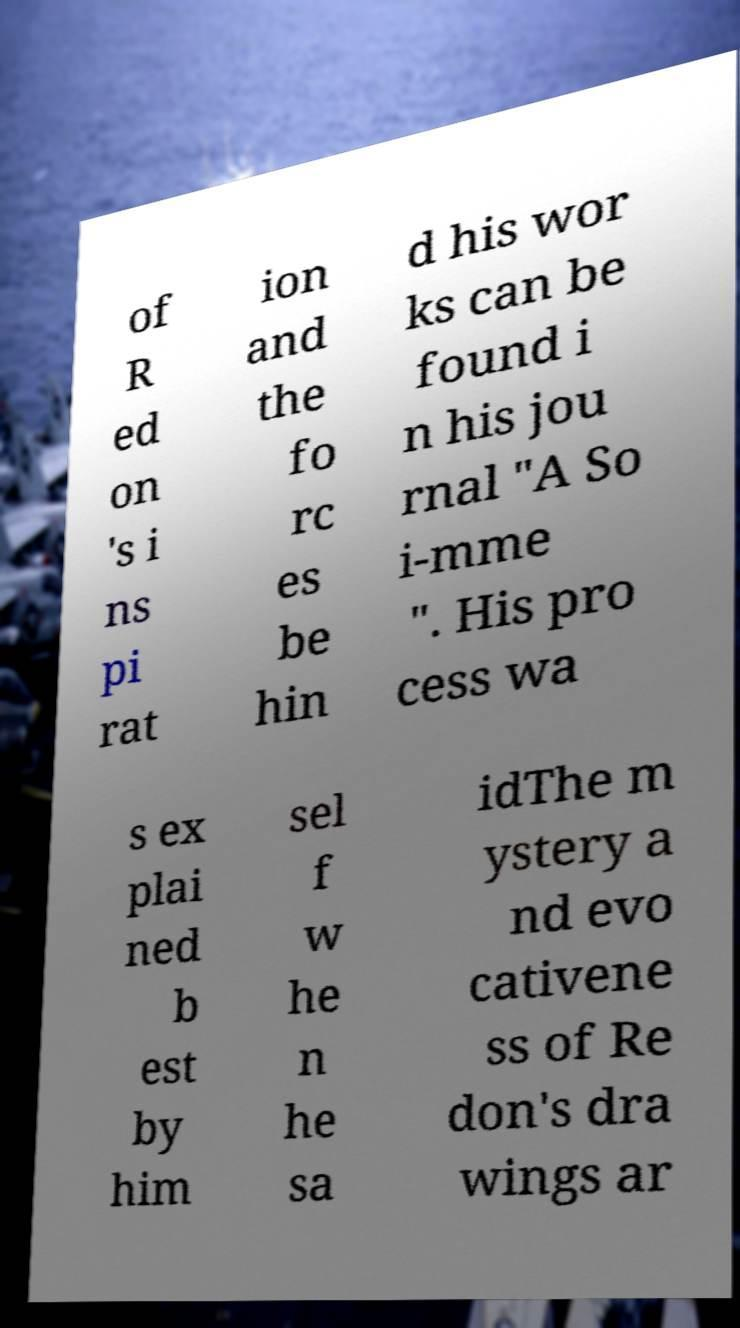Could you assist in decoding the text presented in this image and type it out clearly? of R ed on 's i ns pi rat ion and the fo rc es be hin d his wor ks can be found i n his jou rnal "A So i-mme ". His pro cess wa s ex plai ned b est by him sel f w he n he sa idThe m ystery a nd evo cativene ss of Re don's dra wings ar 